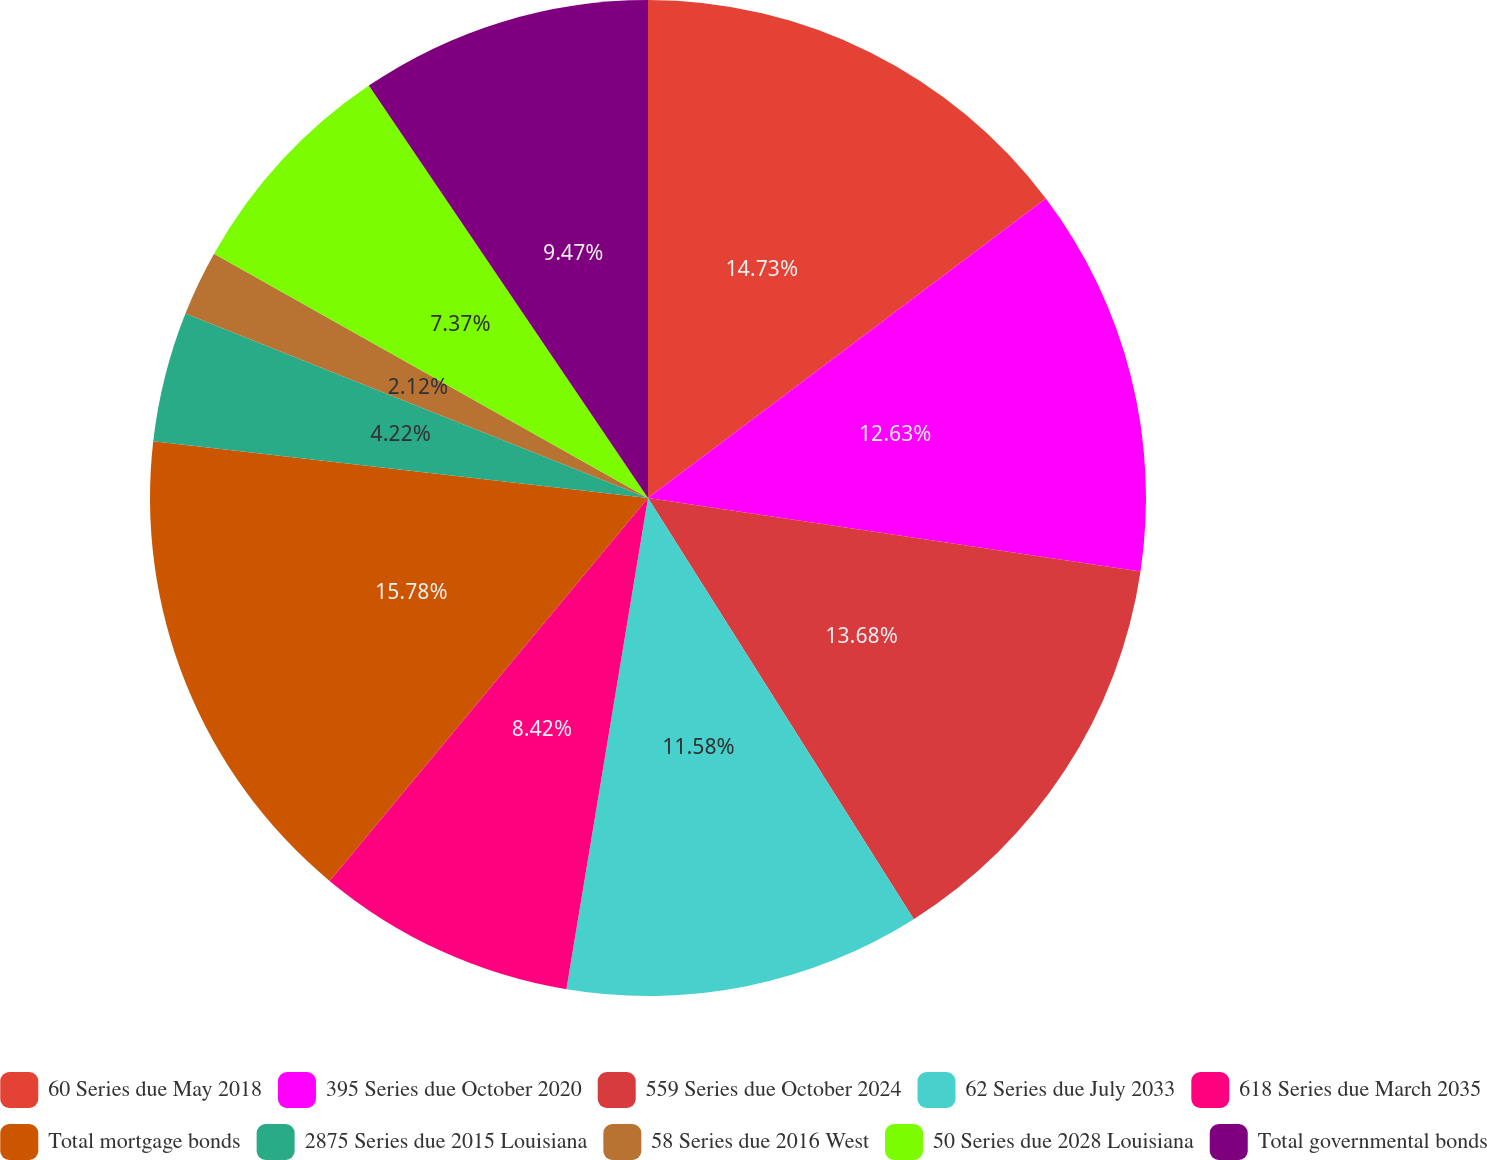Convert chart. <chart><loc_0><loc_0><loc_500><loc_500><pie_chart><fcel>60 Series due May 2018<fcel>395 Series due October 2020<fcel>559 Series due October 2024<fcel>62 Series due July 2033<fcel>618 Series due March 2035<fcel>Total mortgage bonds<fcel>2875 Series due 2015 Louisiana<fcel>58 Series due 2016 West<fcel>50 Series due 2028 Louisiana<fcel>Total governmental bonds<nl><fcel>14.73%<fcel>12.63%<fcel>13.68%<fcel>11.58%<fcel>8.42%<fcel>15.78%<fcel>4.22%<fcel>2.12%<fcel>7.37%<fcel>9.47%<nl></chart> 